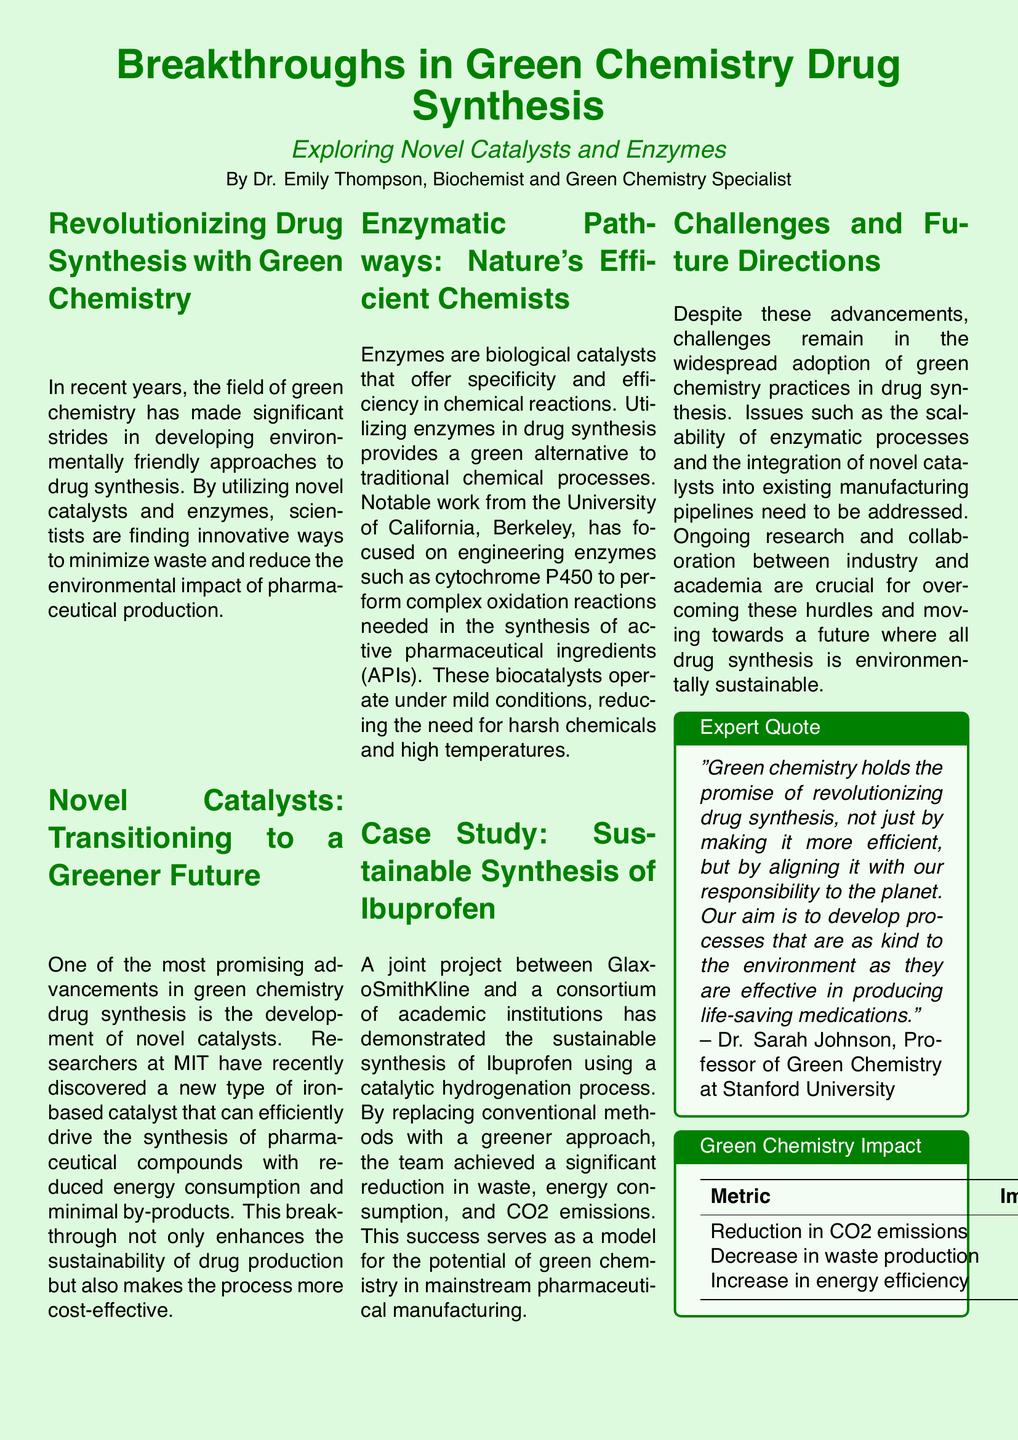What is the main topic of the document? The document discusses advances in drug synthesis through green chemistry, focusing on novel catalysts and enzymes.
Answer: Breakthroughs in Green Chemistry Drug Synthesis Who is the author of the document? The document's author is mentioned at the beginning as the writer and contributes to green chemistry.
Answer: Dr. Emily Thompson What type of catalyst was discovered by researchers at MIT? The document states that MIT researchers discovered a new type of iron-based catalyst for drug synthesis.
Answer: Iron-based catalyst Which enzyme is specifically mentioned in the document as being engineered for drug synthesis? The document highlights the engineering of cytochrome P450 for chemical reactions needed in drug synthesis.
Answer: Cytochrome P450 What percentage reduction in waste production is reported in the document? The document provides specific metrics on improvements in green chemistry, stating a percentage for waste reduction.
Answer: 75% What are the two key areas of focus in this document? The document emphasizes novel catalysts and enzymes as two main areas of innovation in green chemistry.
Answer: Novel catalysts and enzymes What is one challenge to the adoption of green chemistry in drug synthesis mentioned in the document? The document mentions challenges such as the scalability of enzymatic processes in drug manufacturing.
Answer: Scalability of enzymatic processes According to the expert quote, what is a significant benefit of green chemistry? The document contains a quote highlighting the efficiency and environmental responsibility of green chemistry in drug synthesis.
Answer: Efficiency What is the percentage increase in energy efficiency noted in the document? The document includes metrics that detail the improvements in green chemistry practices, including energy efficiency.
Answer: 40% 